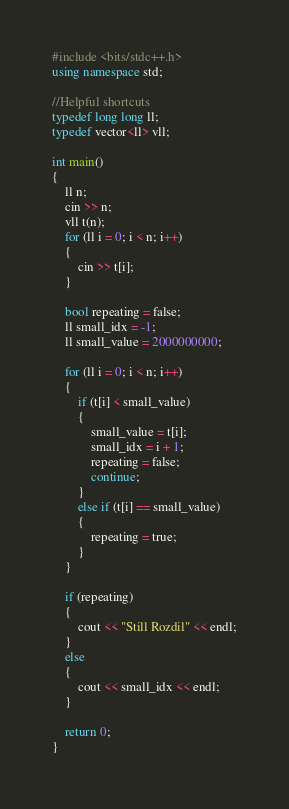<code> <loc_0><loc_0><loc_500><loc_500><_C++_>#include <bits/stdc++.h>
using namespace std;

//Helpful shortcuts
typedef long long ll;
typedef vector<ll> vll;

int main()
{
    ll n;
    cin >> n;
    vll t(n);
    for (ll i = 0; i < n; i++)
    {
        cin >> t[i];
    }

    bool repeating = false;
    ll small_idx = -1;
    ll small_value = 2000000000;

    for (ll i = 0; i < n; i++)
    {
        if (t[i] < small_value)
        {
            small_value = t[i];
            small_idx = i + 1;
            repeating = false;
            continue;
        }
        else if (t[i] == small_value)
        {
            repeating = true;
        }
    }

    if (repeating)
    {
        cout << "Still Rozdil" << endl;
    }
    else
    {
        cout << small_idx << endl;
    }

    return 0;
}
</code> 